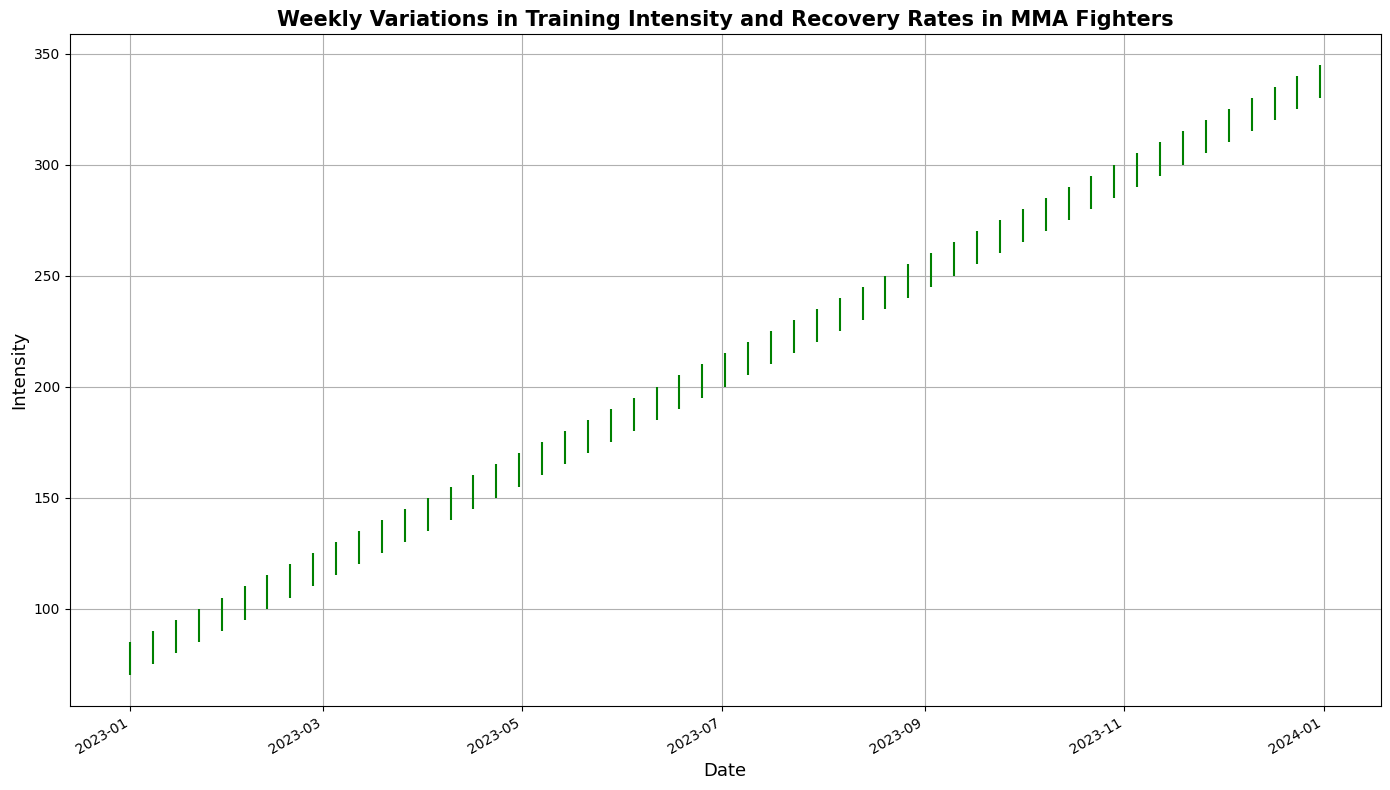What color are the candlestick bodies when the weekly close is higher than the open? The candlestick bodies are colored green when the weekly close is higher than the open. This is because green typically indicates a positive change in value over the period.
Answer: Green What is the general trend of training intensity over the period shown in the chart? The overall trend of the training intensity is upward. The chart shows a consistent increase in the weekly high, low, open, and close values over the entire period from January 2023 to December 2023.
Answer: Upward How many weeks show a decrease in training intensity, where the candlestick body is red? To find the weeks with a red candlestick (indicating a decrease in training intensity), count the red bars visible on the chart. There are no red bars visible—all weeks show an increase, hence no decreases.
Answer: 0 weeks What is the difference between the highest high and the lowest low over the entire period? The highest high is 345 (December 31, 2023), and the lowest low is 70 (January 1, 2023). The difference between them is calculated as 345 - 70.
Answer: 275 Which week shows the single highest training intensity measured by the 'high' value? The week of December 31, 2023, shows the highest training intensity, with the 'high' value reaching 345. This is the tallest candlestick on the chart.
Answer: December 31, 2023 Which month had the most consistent increase in training intensity, meaning each week saw progressively higher closes? By looking for a month where each successive candlestick is higher than the last, both in terms of high, low, and close, May (2023-05-07 to 2023-05-28) has consistent and progressive increases without any dips.
Answer: May What is the average closing value for the last four weeks of 2023? The last four weeks of 2023 (December 10 to December 31) have closing values of 325, 330, 335, and 340. The average is calculated as (325 + 330 + 335 + 340) / 4.
Answer: 332.5 In which weeks do we observe the greatest difference between the high and low values? To determine this, calculate the difference between high and low values for each week and find the maximum. The differences for December vary from 10 to 15, therefore we consider the week with the highest range: December 3, 2023, to December 17, 2023.
Answer: December 3, 2023 What is the cumulative increase in closing values from January 1, 2023, to December 31, 2023? The closing value on January 1 is 80, and on December 31 it is 340. The cumulative increase in closing values is calculated as 340 - 80.
Answer: 260 